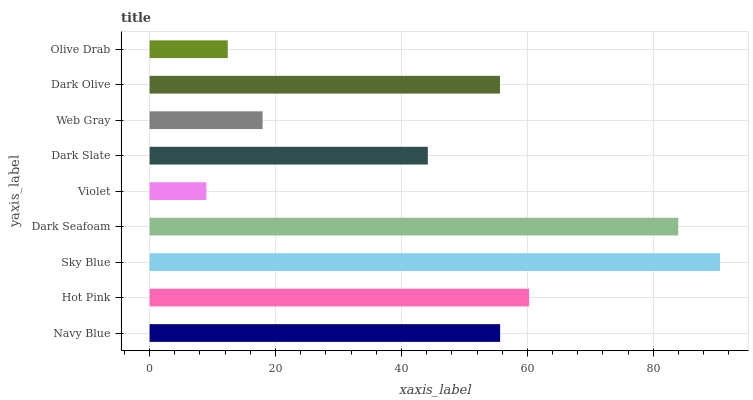Is Violet the minimum?
Answer yes or no. Yes. Is Sky Blue the maximum?
Answer yes or no. Yes. Is Hot Pink the minimum?
Answer yes or no. No. Is Hot Pink the maximum?
Answer yes or no. No. Is Hot Pink greater than Navy Blue?
Answer yes or no. Yes. Is Navy Blue less than Hot Pink?
Answer yes or no. Yes. Is Navy Blue greater than Hot Pink?
Answer yes or no. No. Is Hot Pink less than Navy Blue?
Answer yes or no. No. Is Dark Olive the high median?
Answer yes or no. Yes. Is Dark Olive the low median?
Answer yes or no. Yes. Is Dark Seafoam the high median?
Answer yes or no. No. Is Navy Blue the low median?
Answer yes or no. No. 